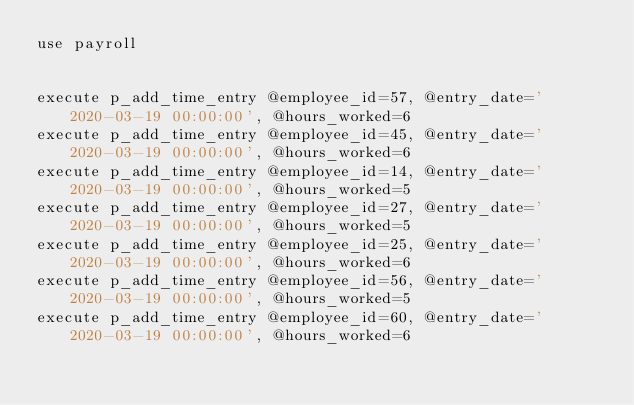Convert code to text. <code><loc_0><loc_0><loc_500><loc_500><_SQL_>use payroll


execute p_add_time_entry @employee_id=57, @entry_date='2020-03-19 00:00:00', @hours_worked=6
execute p_add_time_entry @employee_id=45, @entry_date='2020-03-19 00:00:00', @hours_worked=6
execute p_add_time_entry @employee_id=14, @entry_date='2020-03-19 00:00:00', @hours_worked=5
execute p_add_time_entry @employee_id=27, @entry_date='2020-03-19 00:00:00', @hours_worked=5
execute p_add_time_entry @employee_id=25, @entry_date='2020-03-19 00:00:00', @hours_worked=6
execute p_add_time_entry @employee_id=56, @entry_date='2020-03-19 00:00:00', @hours_worked=5
execute p_add_time_entry @employee_id=60, @entry_date='2020-03-19 00:00:00', @hours_worked=6

</code> 